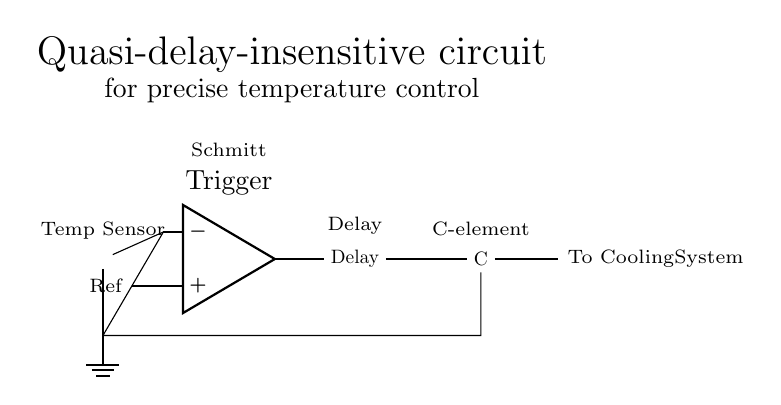What type of sensor is used in this circuit? The circuit features a thermistor, a type of temperature sensor that changes resistance with temperature variations. The symbol shown represents a thermistor directly connected in the circuit.
Answer: thermistor What does the Schmitt trigger do in this circuit? The Schmitt trigger is used to convert the analog signal from the thermistor into a digital signal, providing stable switching with hysteresis. This is crucial for accurate temperature detection and control in the system.
Answer: signal conversion How many main components are visible in the circuit? Counting the distinct elements, we can identify four main components: a thermistor, a Schmitt trigger, a delay element, and a C-element. Each of these plays a specific role in ensuring precise temperature control.
Answer: four What is the function of the delay element? The delay element introduces a timing aspect to the signals in the circuit, ensuring that the control system responds appropriately to changes in temperature and avoids spurious switching caused by noise.
Answer: timing What does the C-element output connect to? The output of the C-element is connected to the cooling system, enabling it to regulate the temperature based on the signal conditions defined by previous components. It ensures that the cooling action is reliable and synchronized with the temperature readings.
Answer: cooling system What does the label 'Ref' next to the Schmitt trigger indicate? The label 'Ref' indicates a reference voltage input to the Schmitt trigger, which is necessary for establishing the threshold levels that determine when the output will change state based on the input from the thermistor.
Answer: reference voltage 